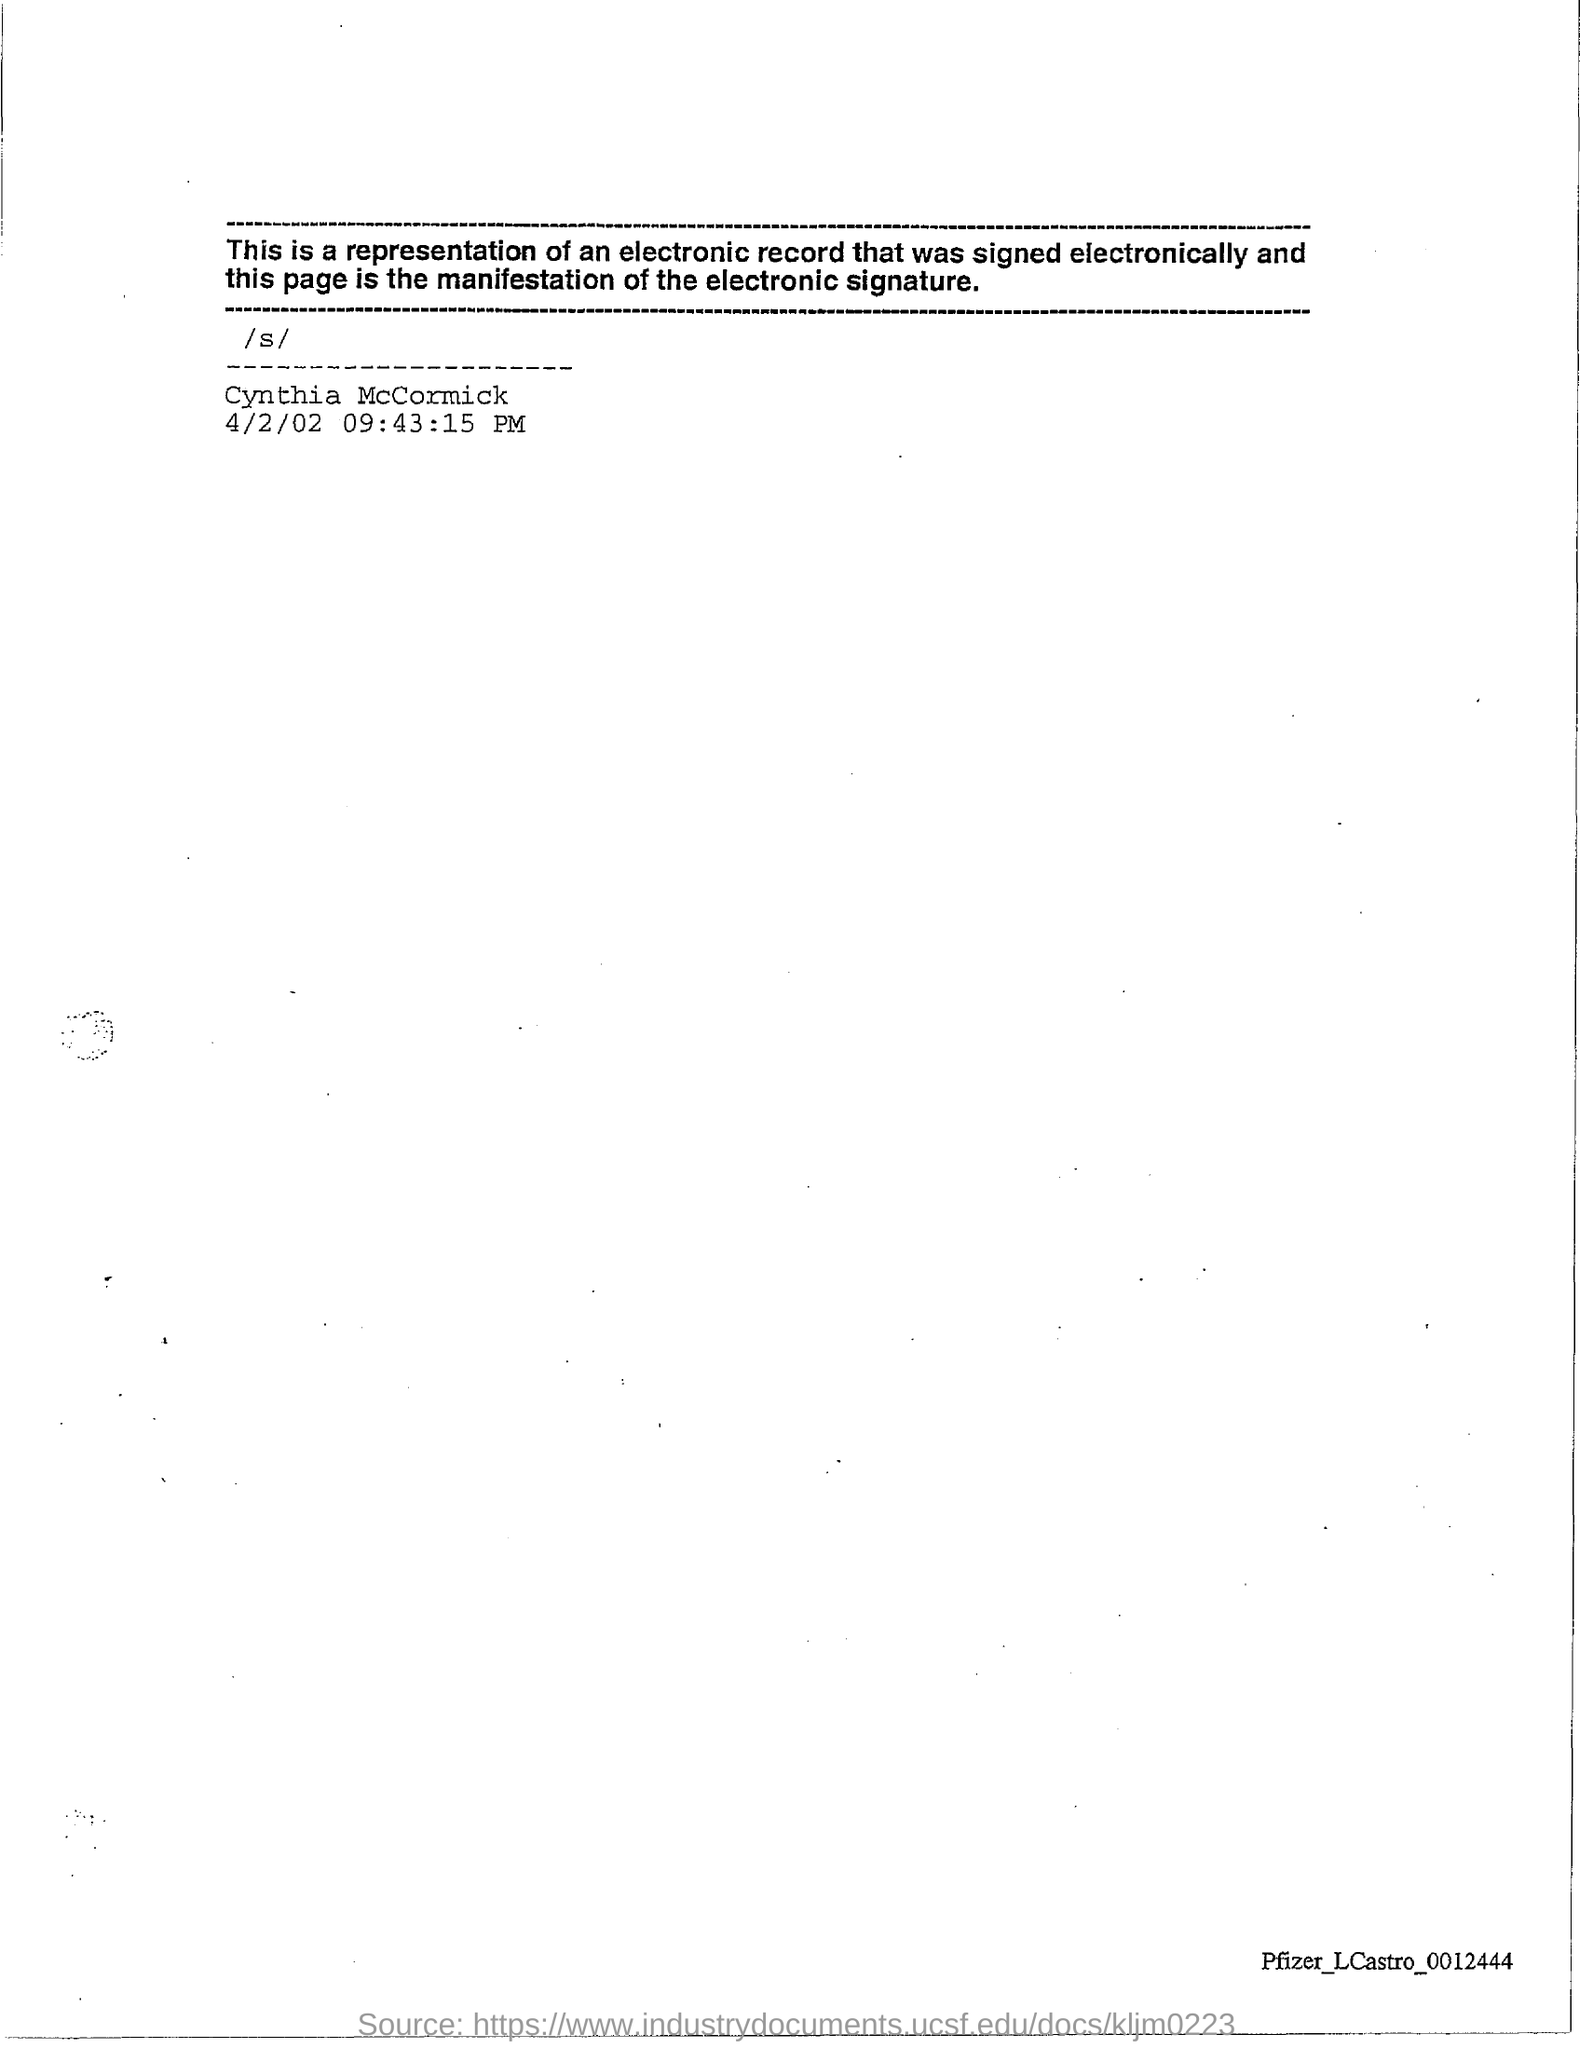Draw attention to some important aspects in this diagram. The date mentioned is April 2, 2002. 